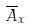Convert formula to latex. <formula><loc_0><loc_0><loc_500><loc_500>\overline { A } _ { x }</formula> 